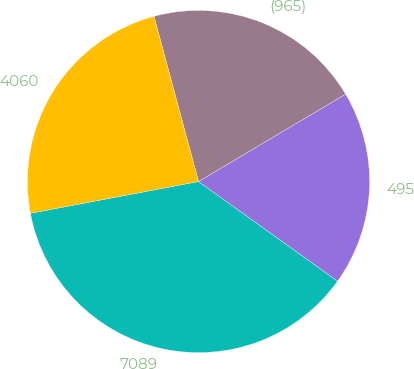Convert chart. <chart><loc_0><loc_0><loc_500><loc_500><pie_chart><fcel>7089<fcel>495<fcel>(965)<fcel>4060<nl><fcel>37.13%<fcel>18.43%<fcel>20.66%<fcel>23.78%<nl></chart> 